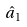<formula> <loc_0><loc_0><loc_500><loc_500>\hat { a } _ { 1 }</formula> 